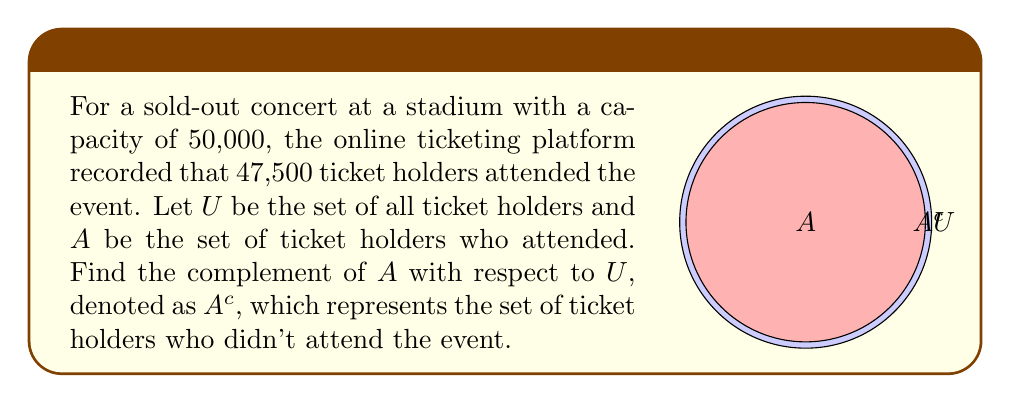Show me your answer to this math problem. Let's approach this step-by-step:

1) First, we need to understand what the complement set $A^c$ represents:
   $A^c = U \setminus A$ (all elements in $U$ that are not in $A$)

2) We know:
   - Total number of ticket holders (size of set $U$) = 50,000
   - Number of attendees (size of set $A$) = 47,500

3) To find the number of ticket holders who didn't attend (size of $A^c$):
   $|A^c| = |U| - |A|$

4) Substituting the values:
   $|A^c| = 50,000 - 47,500 = 2,500$

5) Therefore, the complement set $A^c$ consists of 2,500 ticket holders who didn't attend the event.

6) In set notation, we can express this as:
   $A^c = \{x \in U : x \notin A\}$
   Where $x$ represents a ticket holder.
Answer: $A^c = \{x \in U : x \notin A\}$, where $|A^c| = 2,500$ 